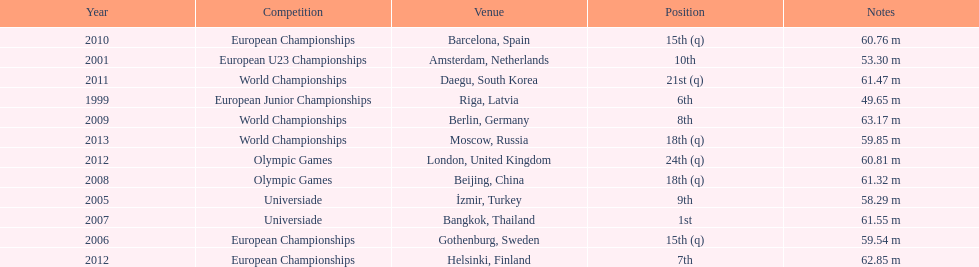What are the total number of times european junior championships is listed as the competition? 1. 